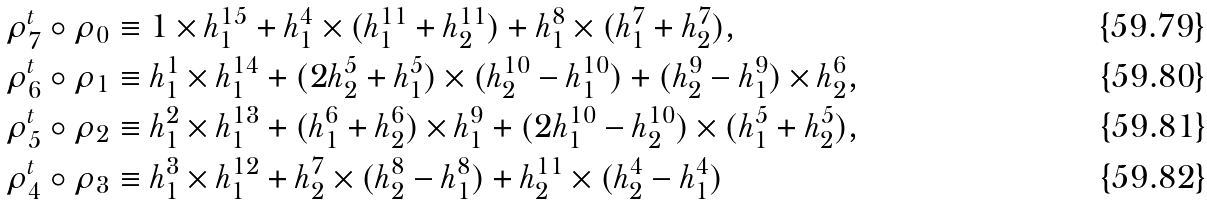Convert formula to latex. <formula><loc_0><loc_0><loc_500><loc_500>\rho _ { 7 } ^ { t } \circ \rho _ { 0 } & \equiv 1 \times h _ { 1 } ^ { 1 5 } + h _ { 1 } ^ { 4 } \times ( h _ { 1 } ^ { 1 1 } + h _ { 2 } ^ { 1 1 } ) + h _ { 1 } ^ { 8 } \times ( h _ { 1 } ^ { 7 } + h _ { 2 } ^ { 7 } ) , \\ \rho _ { 6 } ^ { t } \circ \rho _ { 1 } & \equiv h _ { 1 } ^ { 1 } \times h _ { 1 } ^ { 1 4 } + ( 2 h _ { 2 } ^ { 5 } + h _ { 1 } ^ { 5 } ) \times ( h _ { 2 } ^ { 1 0 } - h _ { 1 } ^ { 1 0 } ) + ( h _ { 2 } ^ { 9 } - h _ { 1 } ^ { 9 } ) \times h _ { 2 } ^ { 6 } , \\ \rho _ { 5 } ^ { t } \circ \rho _ { 2 } & \equiv h _ { 1 } ^ { 2 } \times h _ { 1 } ^ { 1 3 } + ( h _ { 1 } ^ { 6 } + h _ { 2 } ^ { 6 } ) \times h _ { 1 } ^ { 9 } + ( 2 h _ { 1 } ^ { 1 0 } - h _ { 2 } ^ { 1 0 } ) \times ( h _ { 1 } ^ { 5 } + h _ { 2 } ^ { 5 } ) , \\ \rho _ { 4 } ^ { t } \circ \rho _ { 3 } & \equiv h _ { 1 } ^ { 3 } \times h _ { 1 } ^ { 1 2 } + h _ { 2 } ^ { 7 } \times ( h _ { 2 } ^ { 8 } - h _ { 1 } ^ { 8 } ) + h _ { 2 } ^ { 1 1 } \times ( h _ { 2 } ^ { 4 } - h _ { 1 } ^ { 4 } )</formula> 